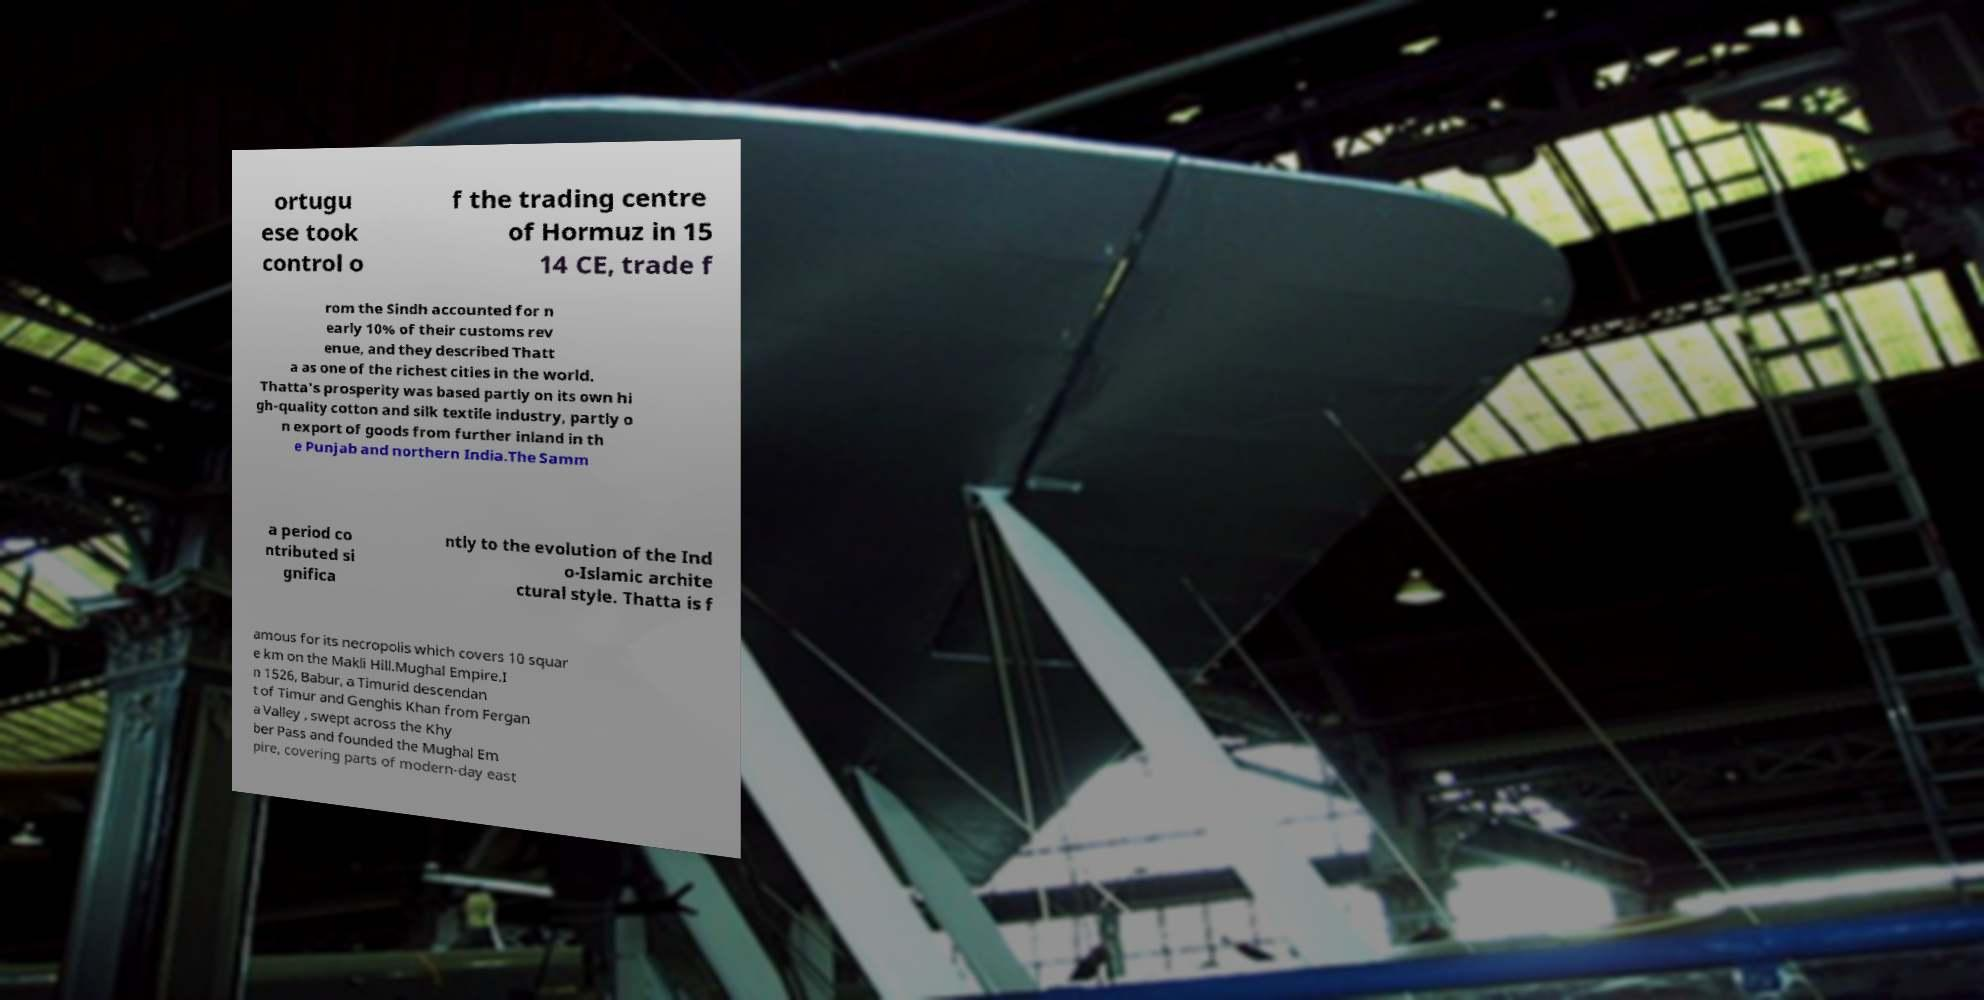Can you accurately transcribe the text from the provided image for me? ortugu ese took control o f the trading centre of Hormuz in 15 14 CE, trade f rom the Sindh accounted for n early 10% of their customs rev enue, and they described Thatt a as one of the richest cities in the world. Thatta's prosperity was based partly on its own hi gh-quality cotton and silk textile industry, partly o n export of goods from further inland in th e Punjab and northern India.The Samm a period co ntributed si gnifica ntly to the evolution of the Ind o-Islamic archite ctural style. Thatta is f amous for its necropolis which covers 10 squar e km on the Makli Hill.Mughal Empire.I n 1526, Babur, a Timurid descendan t of Timur and Genghis Khan from Fergan a Valley , swept across the Khy ber Pass and founded the Mughal Em pire, covering parts of modern-day east 